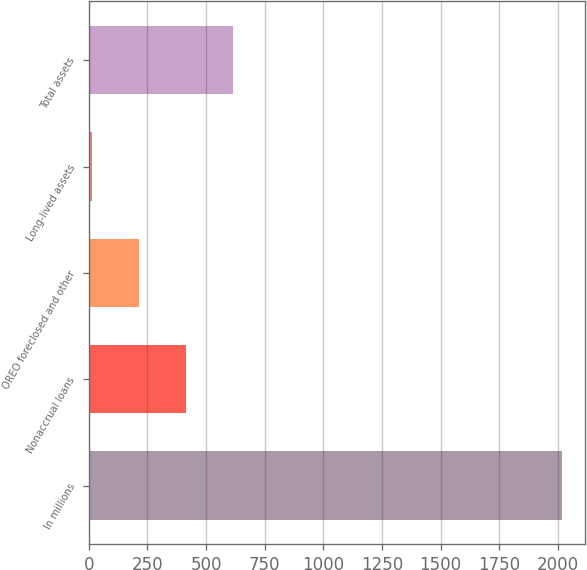Convert chart to OTSL. <chart><loc_0><loc_0><loc_500><loc_500><bar_chart><fcel>In millions<fcel>Nonaccrual loans<fcel>OREO foreclosed and other<fcel>Long-lived assets<fcel>Total assets<nl><fcel>2016<fcel>415.2<fcel>215.1<fcel>15<fcel>615.3<nl></chart> 